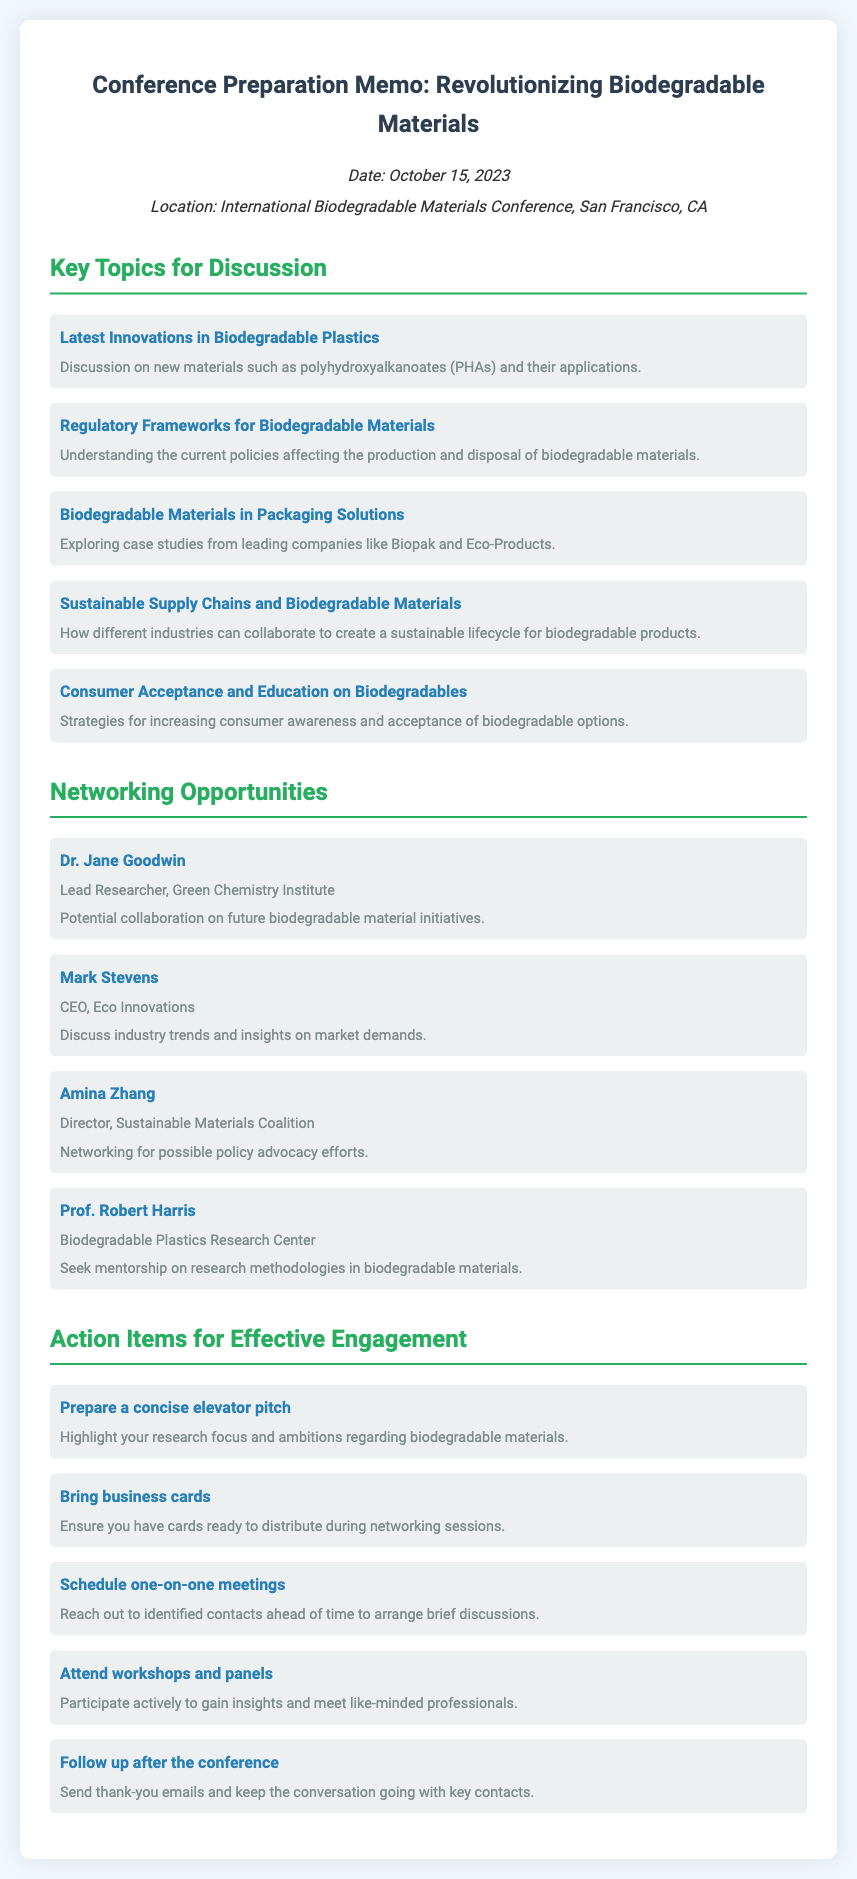What is the date of the conference? The date of the conference is clearly stated in the memo as October 15, 2023.
Answer: October 15, 2023 Who is the CEO of Eco Innovations? The memo lists Mark Stevens as the CEO of Eco Innovations.
Answer: Mark Stevens What is one key topic discussed regarding consumer awareness? The memo mentions "Strategies for increasing consumer awareness and acceptance of biodegradable options" under key topics for discussion.
Answer: Consumer Acceptance and Education on Biodegradables What is an action item regarding networking materials? The memo advises to "Bring business cards" as an essential action item for networking.
Answer: Bring business cards Which organization does Dr. Jane Goodwin belong to? The affiliation of Dr. Jane Goodwin is stated in the memo as Lead Researcher, Green Chemistry Institute.
Answer: Green Chemistry Institute How many networking contacts are mentioned in the memo? The memo lists four networking opportunities with key individuals in the field.
Answer: Four What is one purpose of networking with Amina Zhang? The memo indicates that networking with Amina Zhang is for "possible policy advocacy efforts."
Answer: Policy advocacy efforts What is suggested to prepare for networking engagements? The memo emphasizes the importance of preparing a "concise elevator pitch" to communicate effectively.
Answer: Concise elevator pitch 